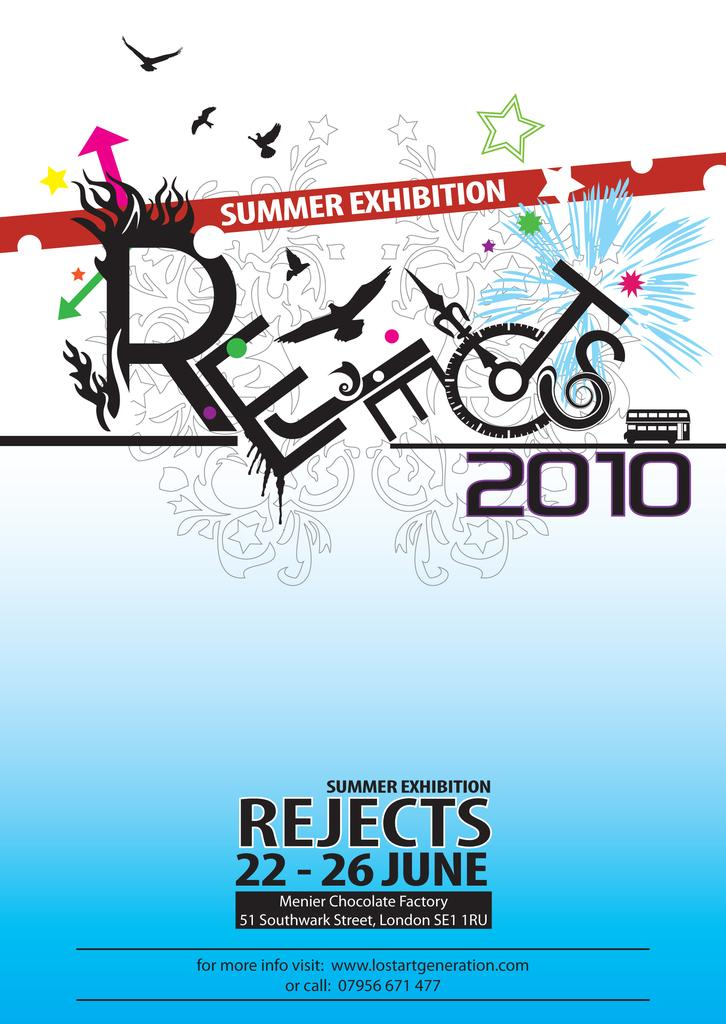<image>
Summarize the visual content of the image. A poster for the summer exhibition rejects in 2010. 